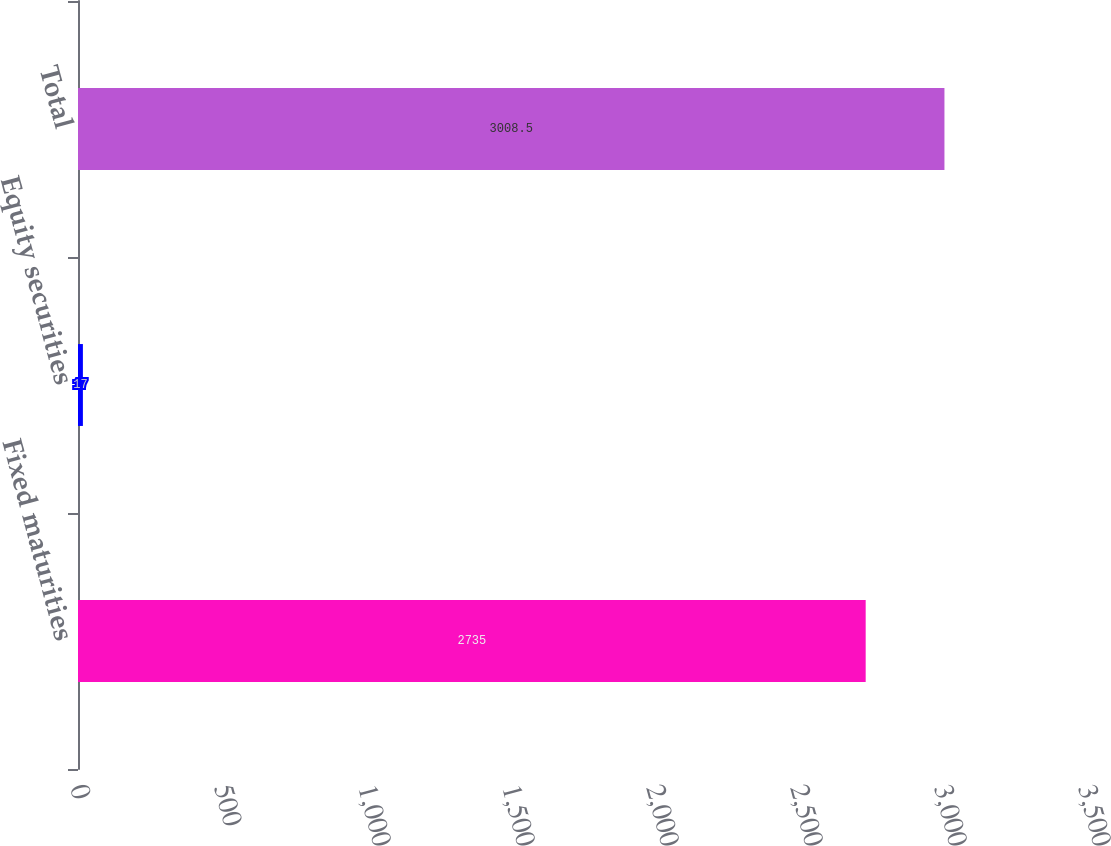<chart> <loc_0><loc_0><loc_500><loc_500><bar_chart><fcel>Fixed maturities<fcel>Equity securities<fcel>Total<nl><fcel>2735<fcel>17<fcel>3008.5<nl></chart> 